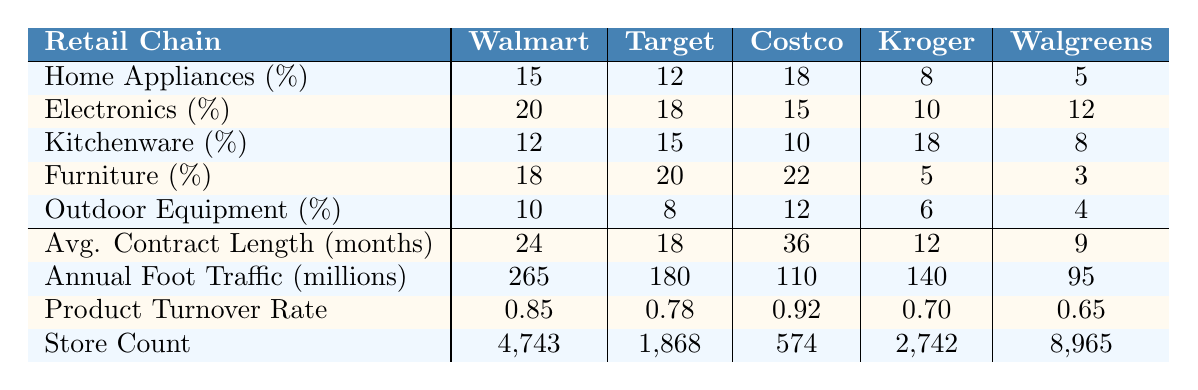What retail chain has the highest shelf space percentage for Home Appliances? In the Home Appliances category, the percentages are 15 for Walmart, 12 for Target, 18 for Costco, 8 for Kroger, and 5 for Walgreens. Therefore, Costco has the highest percentage.
Answer: Costco Which retail chain allocates the least shelf space to Electronics? Looking at the Electronics percentages, they are 20 for Walmart, 18 for Target, 15 for Costco, 10 for Kroger, and 12 for Walgreens. Kroger has the least shelf space allocated.
Answer: Kroger What is the average shelf space percentage for Furniture among all retail chains? The shelf space percentages for Furniture are: 18 (Walmart), 20 (Target), 22 (Costco), 5 (Kroger), and 3 (Walgreens). The average is calculated as (18 + 20 + 22 + 5 + 3) / 5 = 13.6.
Answer: 13.6 What is the total shelf space percentage for Outdoor Equipment across all retail chains? The percentages for Outdoor Equipment are: 10 (Walmart), 8 (Target), 12 (Costco), 6 (Kroger), and 4 (Walgreens). Summing them gives 10 + 8 + 12 + 6 + 4 = 40.
Answer: 40 Which retail chain has the longest average contract length in months? The average contract lengths are 24 for Walmart, 18 for Target, 36 for Costco, 12 for Kroger, and 9 for Walgreens. Costco has the longest average contract length.
Answer: Costco Is Kroger's product turnover rate higher than Walgreens'? Kroger has a turnover rate of 0.70 and Walgreens has 0.65. Since 0.70 is greater than 0.65, the statement is true.
Answer: Yes Which retail chain has the highest annual foot traffic? The annual foot traffic numbers are: Walmart (265 million), Target (180 million), Costco (110 million), Kroger (140 million), and Walgreens (95 million). Walmart has the highest foot traffic.
Answer: Walmart How does Walmart's shelf space allocation for Kitchenware compare to Target's? Walmart allocates 12% for Kitchenware while Target allocates 15%. Target has a higher allocation than Walmart.
Answer: Target Calculate the difference in annual foot traffic between Target and Costco. Target has 180 million in foot traffic and Costco has 110 million. The difference is 180 - 110 = 70 million.
Answer: 70 million If a retailer wants to maximize their product turnover rate while having a good contract length, which retail chain should they consider? The highest turnover rate is 0.92 for Costco and the longest contract length is 36 months also for Costco. Thus, Costco provides the best combination.
Answer: Costco 